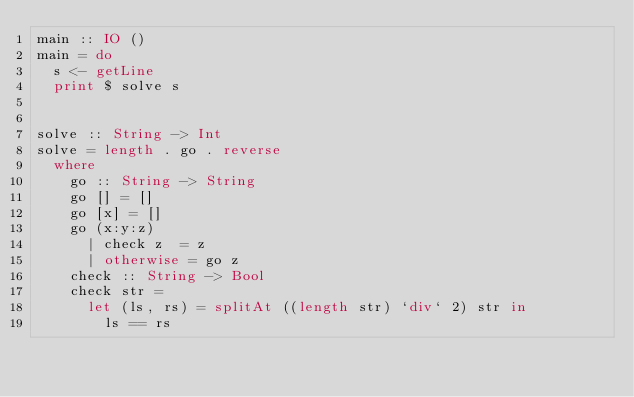<code> <loc_0><loc_0><loc_500><loc_500><_Haskell_>main :: IO ()
main = do
  s <- getLine
  print $ solve s
  

solve :: String -> Int
solve = length . go . reverse 
  where
    go :: String -> String
    go [] = []
    go [x] = []
    go (x:y:z)
      | check z  = z
      | otherwise = go z
    check :: String -> Bool
    check str =
      let (ls, rs) = splitAt ((length str) `div` 2) str in
        ls == rs
   
</code> 